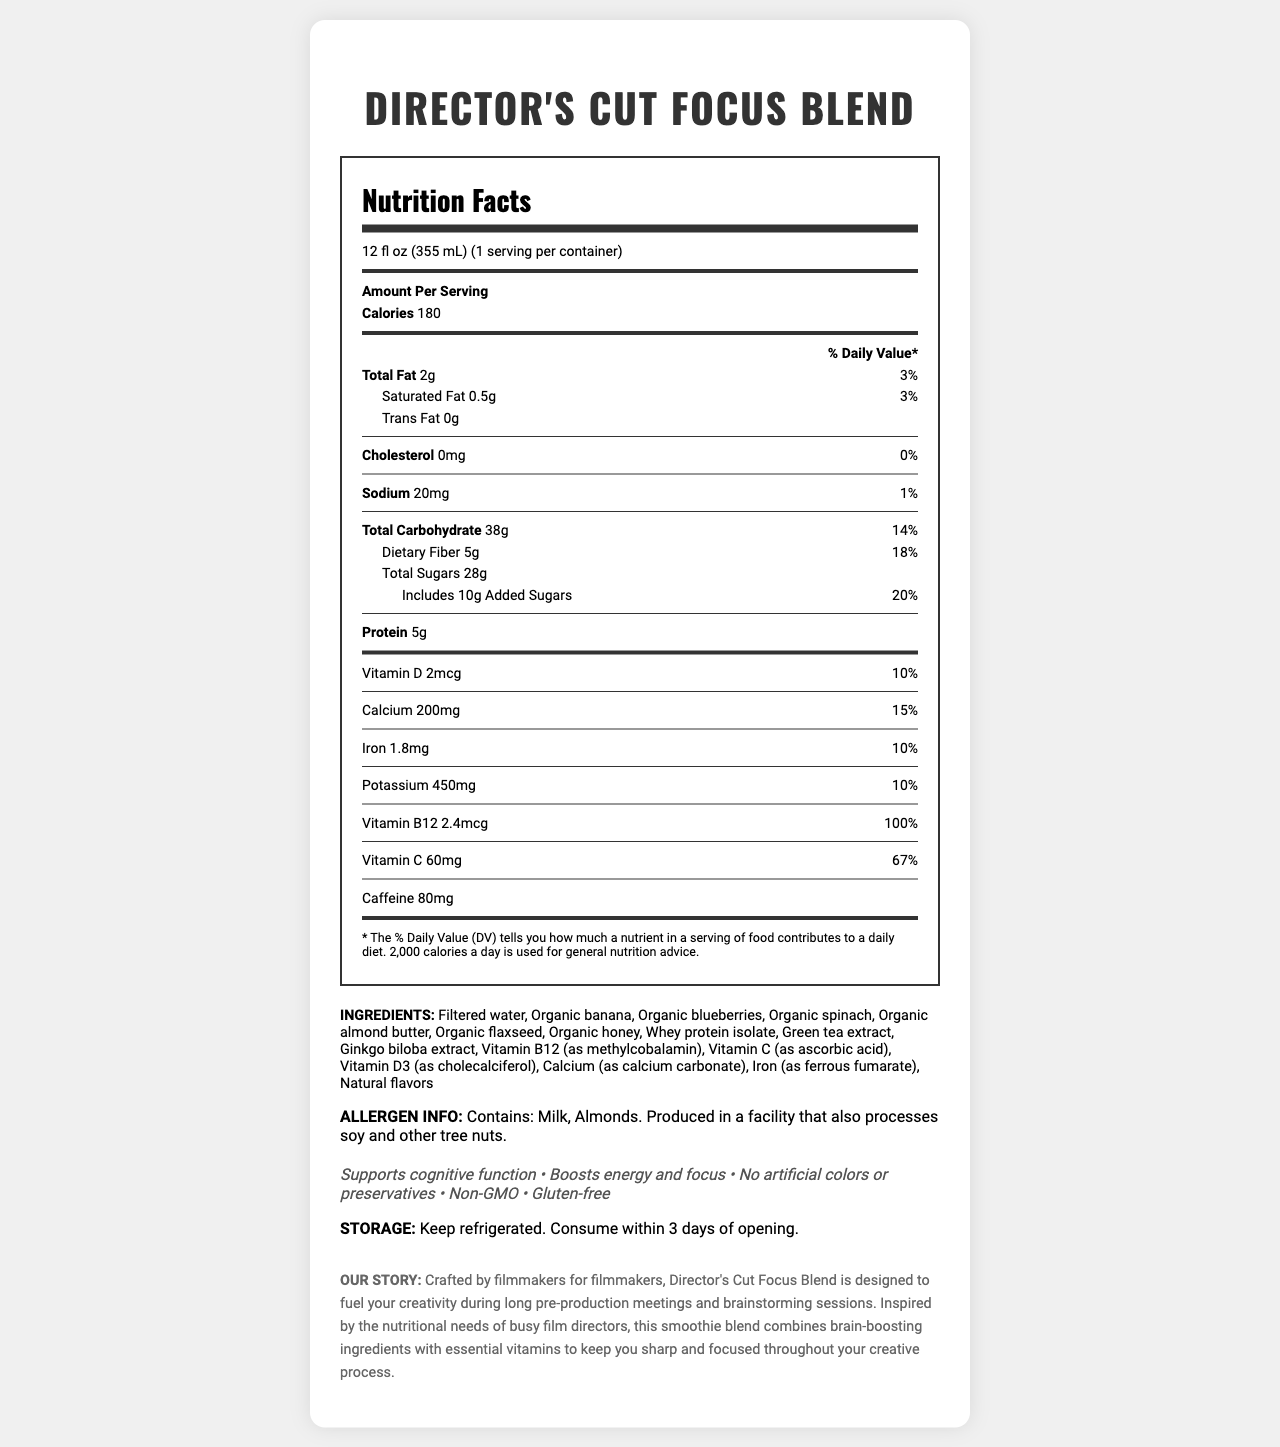What is the serving size of Director's Cut Focus Blend? The serving size is clearly listed at the top of the nutrition facts label as "12 fl oz (355 mL)."
Answer: 12 fl oz (355 mL) How many calories are in one serving of this smoothie blend? The number of calories per serving is stated in the nutrition facts section.
Answer: 180 calories What percentage of the daily value for dietary fiber does this smoothie provide? This information is under the dietary fiber heading in the nutrition facts table.
Answer: 18% What is the amount of added sugars in this smoothie blend? The amount of added sugars is listed in the total carbohydrate section under "Includes 10g Added Sugars."
Answer: 10g How much protein does one serving of Director's Cut Focus Blend contain? The protein content per serving is specified in the nutrition facts.
Answer: 5g Which of the following vitamins are present at 100% daily value in the smoothie? A. Vitamin D B. Vitamin B12 C. Vitamin C D. Iron The document states that Vitamin B12 is present at "100%" daily value, making it the correct choice.
Answer: B. Vitamin B12 The smoothie contains which allergen(s)? A. Milk B. Almonds C. Soy D. Both A and B The allergen info section mentions the presence of both Milk and Almonds, making option D correct.
Answer: D. Both A and B Is this product gluten-free? The claims section lists "Gluten-free," indicating that the product contains no gluten.
Answer: Yes How should the smoothie be stored after opening? The storage instructions specify that it should be refrigerated and consumed within 3 days.
Answer: Keep refrigerated. Consume within 3 days of opening. What is the main purpose of the Director's Cut Focus Blend smoothie? This main idea is summarized in the brand story section.
Answer: To fuel creativity and keep filmmakers focused during pre-production meetings and brainstorming sessions. Does this product contain any trans fat? The nutrition facts label indicates "Trans Fat 0g," meaning it contains no trans fat.
Answer: No What is the flavoring used in the smoothie? The document lists "Natural flavors" but does not specify the exact flavoring used.
Answer: Cannot be determined 